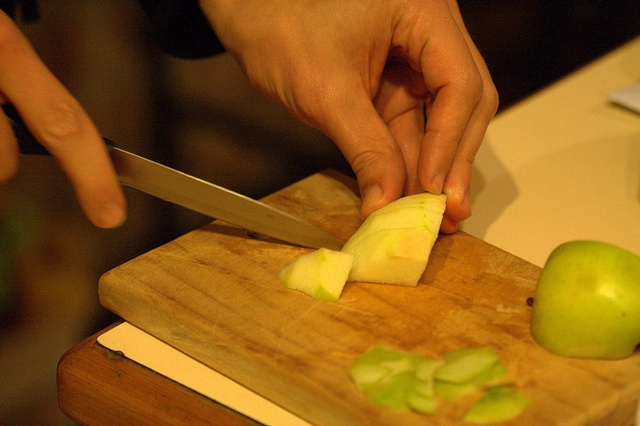Describe the objects in this image and their specific colors. I can see people in black, red, and maroon tones, apple in black, olive, and gold tones, apple in black, olive, gold, and orange tones, knife in black and maroon tones, and apple in black, orange, gold, and red tones in this image. 